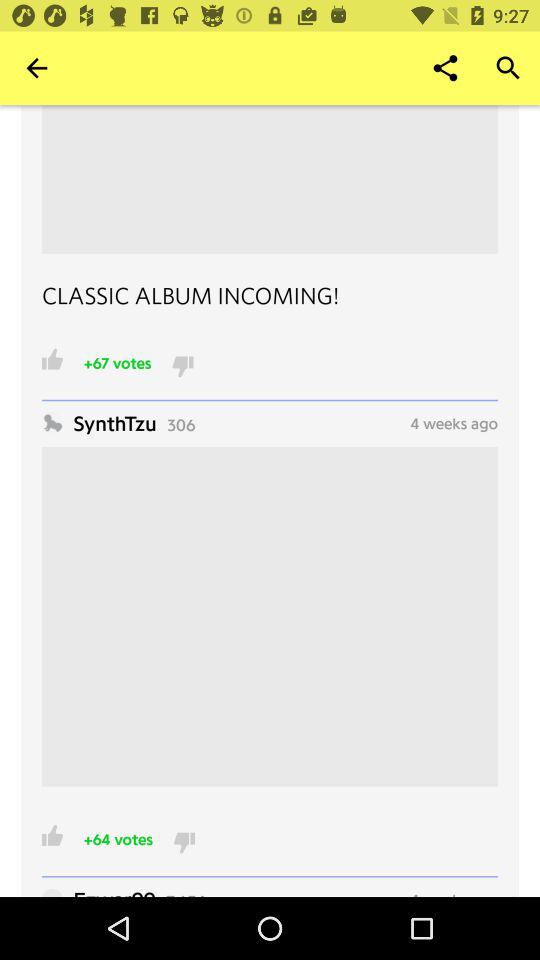How many more thumbs up does the first post have than the second post?
Answer the question using a single word or phrase. 3 